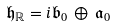<formula> <loc_0><loc_0><loc_500><loc_500>\mathfrak { h } _ { \mathbb { R } } = i \mathfrak { b } _ { 0 } \, \oplus \, \mathfrak { a } _ { 0 }</formula> 